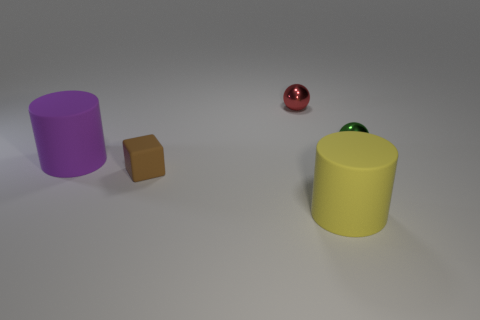How big is the rubber cylinder that is behind the yellow object?
Make the answer very short. Large. What number of things are both to the right of the purple thing and behind the small brown object?
Make the answer very short. 2. What material is the cylinder behind the big cylinder that is right of the tiny block made of?
Provide a succinct answer. Rubber. There is a purple object that is the same shape as the big yellow rubber object; what is its material?
Provide a succinct answer. Rubber. Are there any large metallic cylinders?
Your response must be concise. No. There is a yellow thing that is made of the same material as the big purple object; what is its shape?
Keep it short and to the point. Cylinder. What is the big thing behind the large yellow rubber cylinder made of?
Offer a terse response. Rubber. There is a sphere that is to the right of the large thing to the right of the purple thing; what is its size?
Your answer should be compact. Small. Are there more small shiny objects that are to the left of the green object than big purple balls?
Make the answer very short. Yes. There is a rubber object behind the brown cube; does it have the same size as the yellow rubber cylinder?
Offer a very short reply. Yes. 